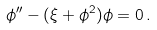Convert formula to latex. <formula><loc_0><loc_0><loc_500><loc_500>\phi ^ { \prime \prime } - ( \xi + \phi ^ { 2 } ) \phi = 0 \, .</formula> 